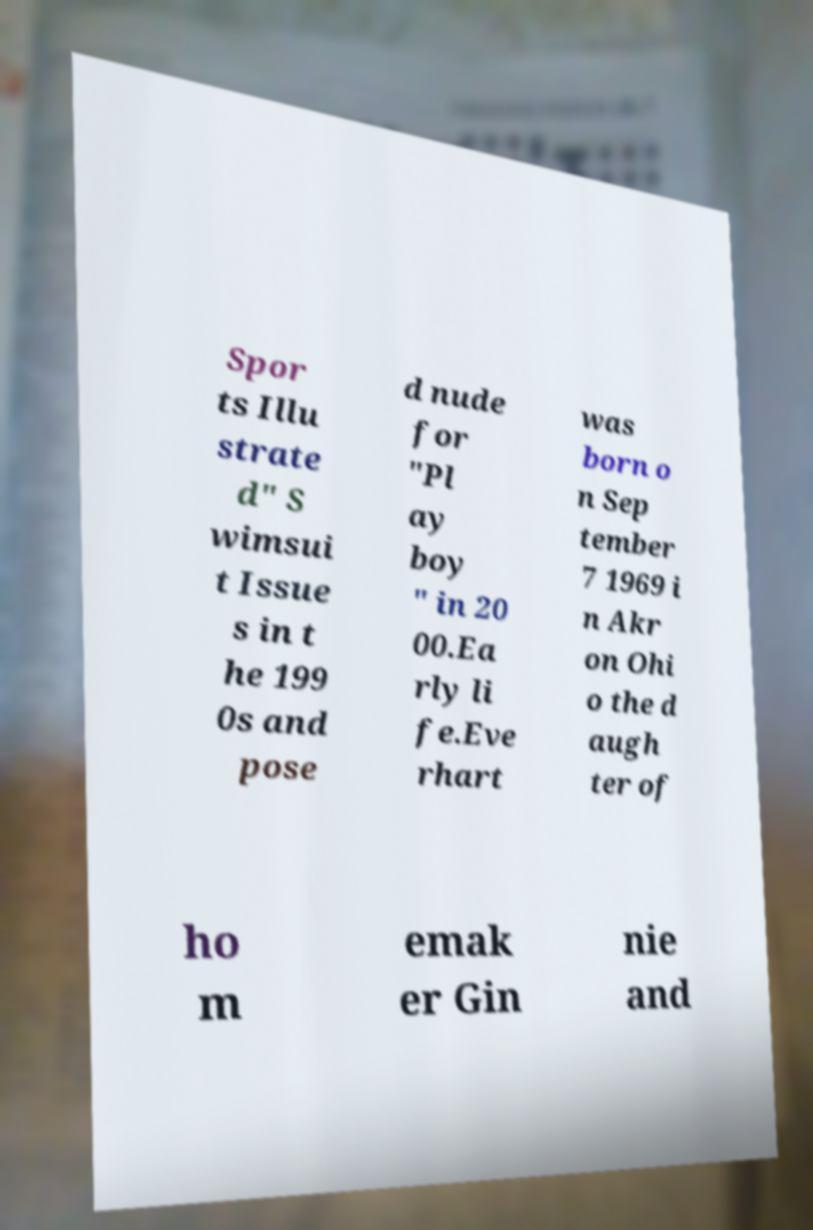What messages or text are displayed in this image? I need them in a readable, typed format. Spor ts Illu strate d" S wimsui t Issue s in t he 199 0s and pose d nude for "Pl ay boy " in 20 00.Ea rly li fe.Eve rhart was born o n Sep tember 7 1969 i n Akr on Ohi o the d augh ter of ho m emak er Gin nie and 